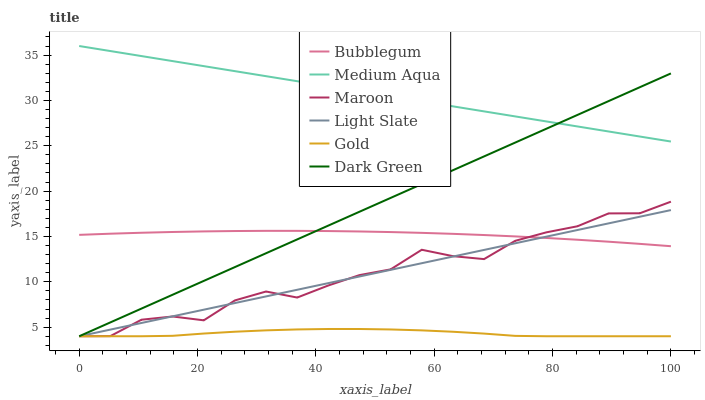Does Gold have the minimum area under the curve?
Answer yes or no. Yes. Does Medium Aqua have the maximum area under the curve?
Answer yes or no. Yes. Does Light Slate have the minimum area under the curve?
Answer yes or no. No. Does Light Slate have the maximum area under the curve?
Answer yes or no. No. Is Dark Green the smoothest?
Answer yes or no. Yes. Is Maroon the roughest?
Answer yes or no. Yes. Is Light Slate the smoothest?
Answer yes or no. No. Is Light Slate the roughest?
Answer yes or no. No. Does Gold have the lowest value?
Answer yes or no. Yes. Does Medium Aqua have the lowest value?
Answer yes or no. No. Does Medium Aqua have the highest value?
Answer yes or no. Yes. Does Light Slate have the highest value?
Answer yes or no. No. Is Gold less than Medium Aqua?
Answer yes or no. Yes. Is Medium Aqua greater than Bubblegum?
Answer yes or no. Yes. Does Dark Green intersect Medium Aqua?
Answer yes or no. Yes. Is Dark Green less than Medium Aqua?
Answer yes or no. No. Is Dark Green greater than Medium Aqua?
Answer yes or no. No. Does Gold intersect Medium Aqua?
Answer yes or no. No. 